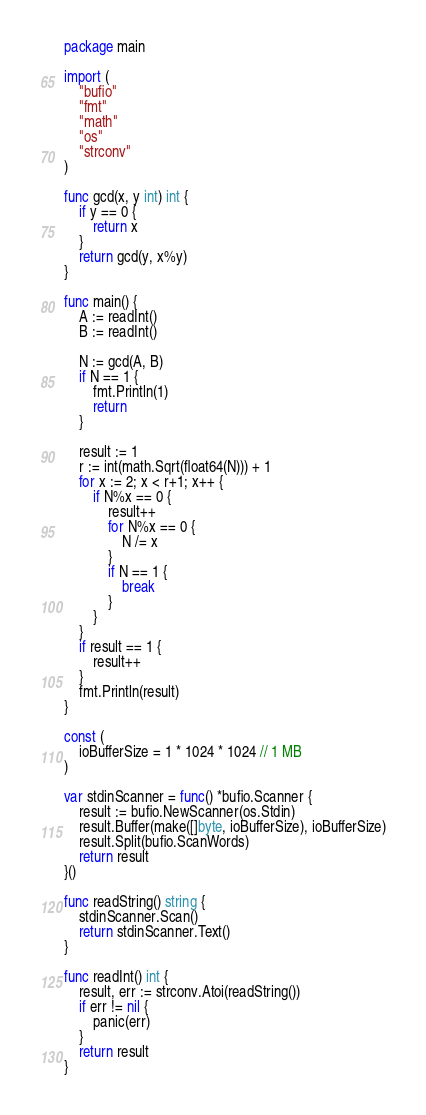<code> <loc_0><loc_0><loc_500><loc_500><_Go_>package main

import (
	"bufio"
	"fmt"
	"math"
	"os"
	"strconv"
)

func gcd(x, y int) int {
	if y == 0 {
		return x
	}
	return gcd(y, x%y)
}

func main() {
	A := readInt()
	B := readInt()

	N := gcd(A, B)
	if N == 1 {
		fmt.Println(1)
		return
	}

	result := 1
	r := int(math.Sqrt(float64(N))) + 1
	for x := 2; x < r+1; x++ {
		if N%x == 0 {
			result++
			for N%x == 0 {
				N /= x
			}
			if N == 1 {
				break
			}
		}
	}
	if result == 1 {
		result++
	}
	fmt.Println(result)
}

const (
	ioBufferSize = 1 * 1024 * 1024 // 1 MB
)

var stdinScanner = func() *bufio.Scanner {
	result := bufio.NewScanner(os.Stdin)
	result.Buffer(make([]byte, ioBufferSize), ioBufferSize)
	result.Split(bufio.ScanWords)
	return result
}()

func readString() string {
	stdinScanner.Scan()
	return stdinScanner.Text()
}

func readInt() int {
	result, err := strconv.Atoi(readString())
	if err != nil {
		panic(err)
	}
	return result
}
</code> 